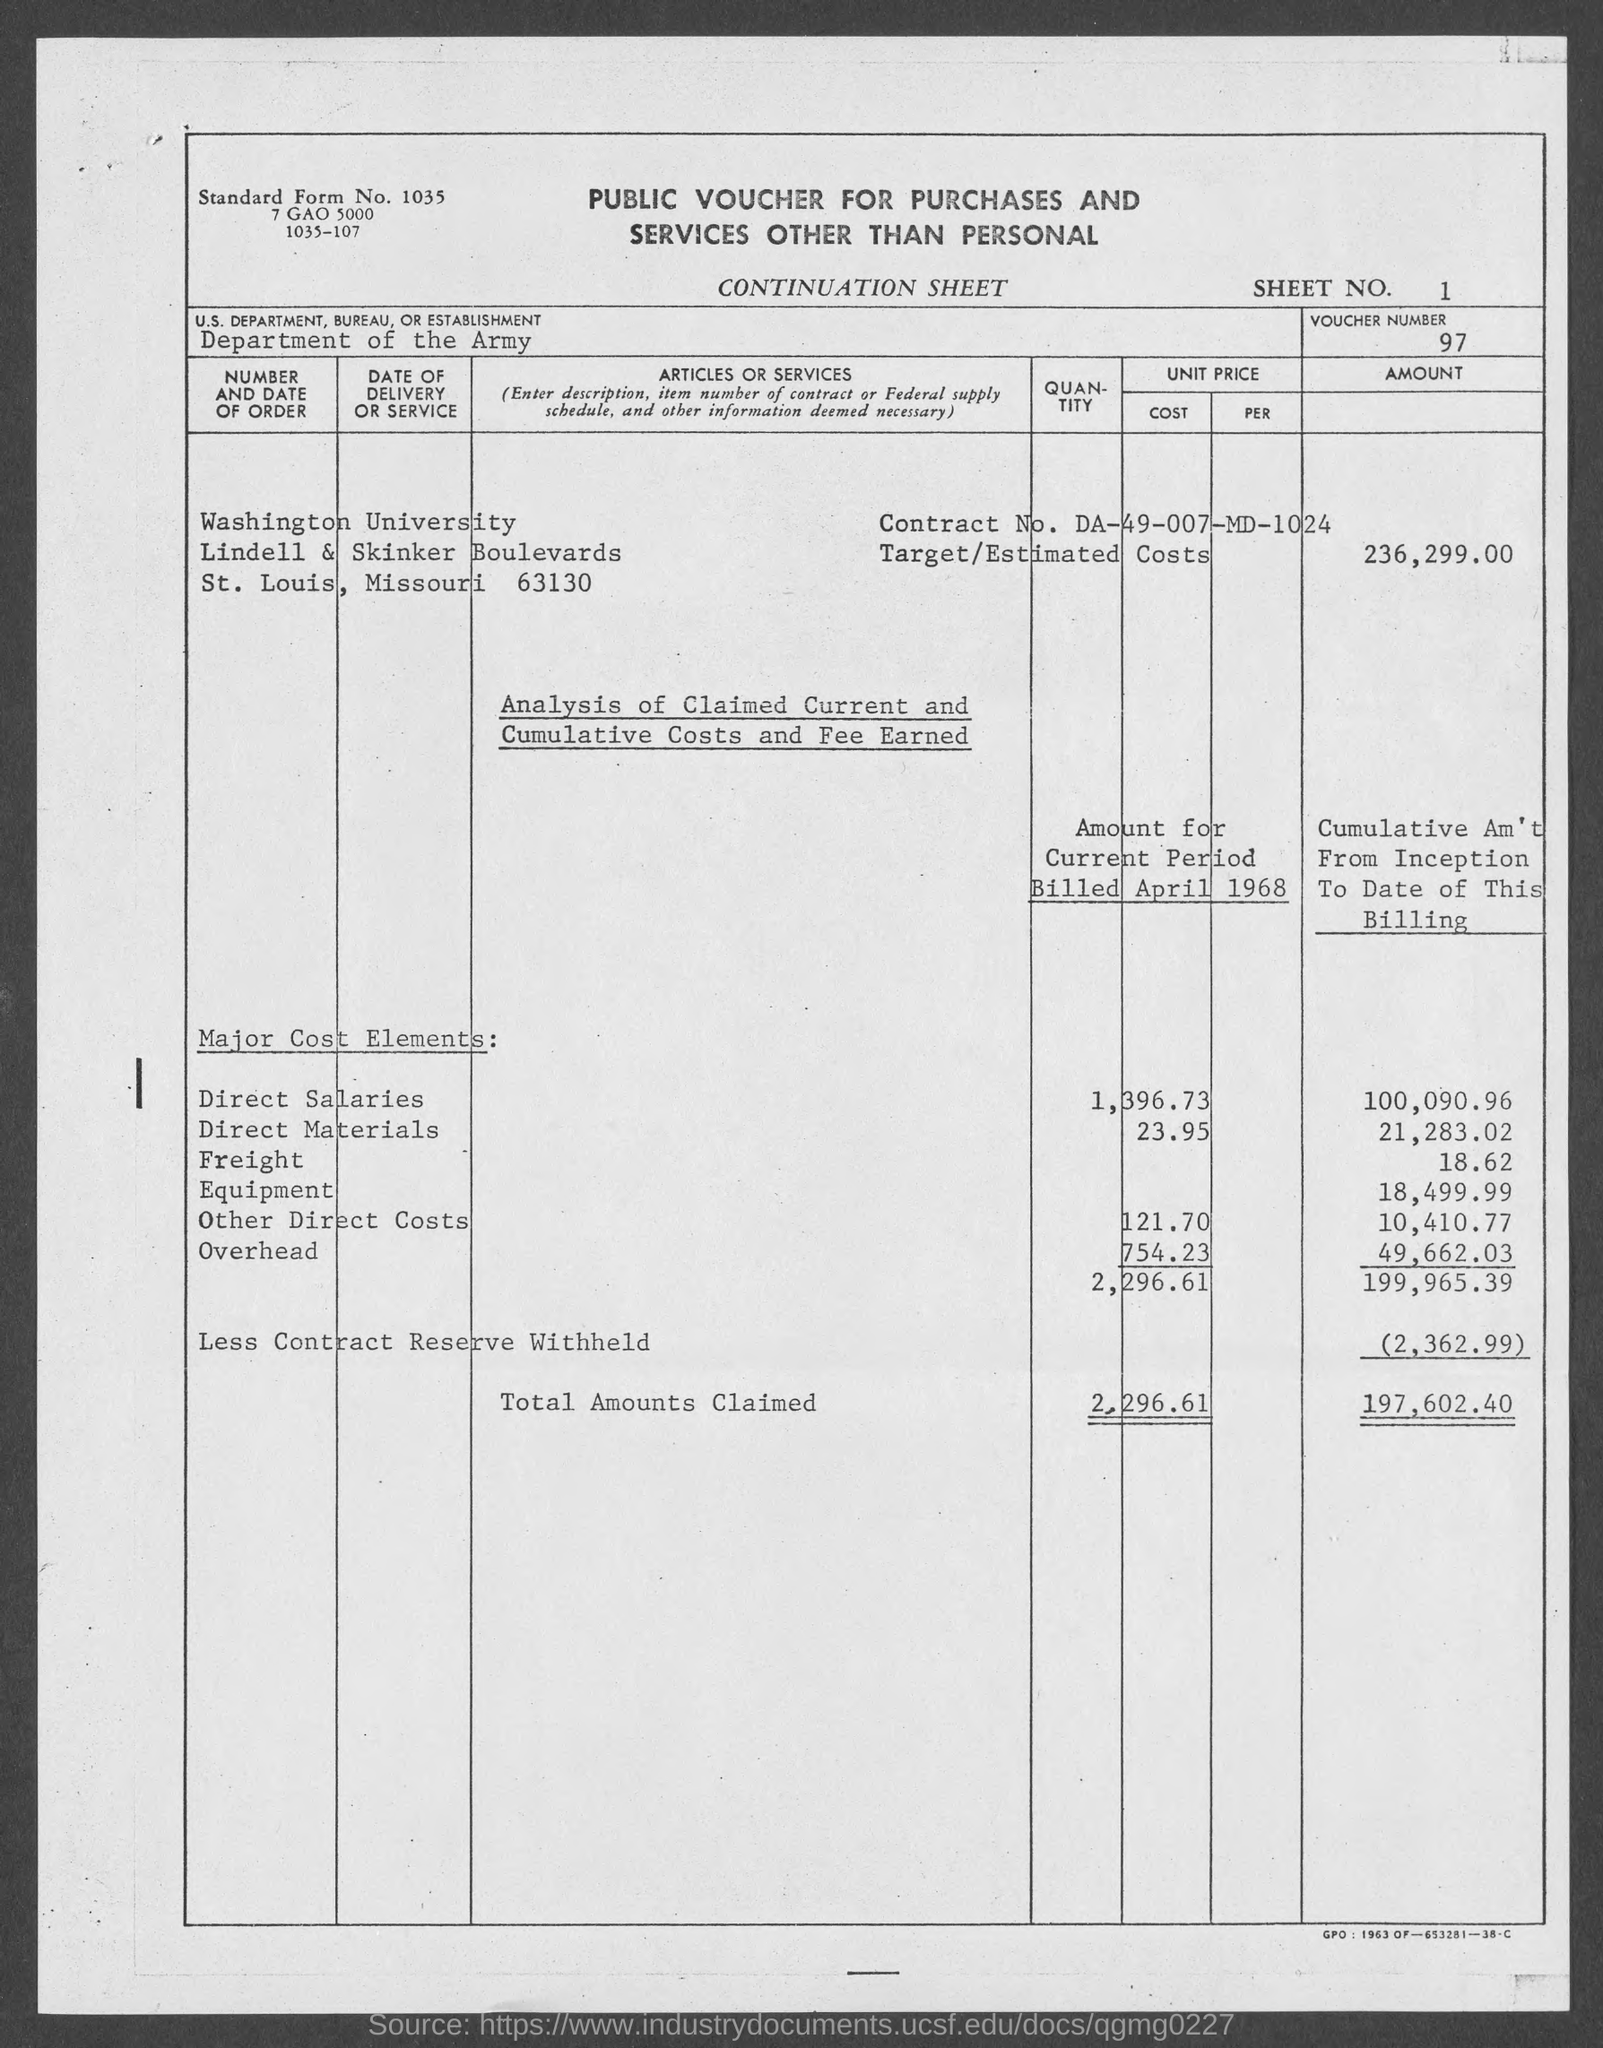What is the sheet no.?
Give a very brief answer. 1. What is the voucher number ?
Offer a very short reply. 97. What is the us. department, bureau, or establishment in voucher?
Provide a short and direct response. Department of the army. What is the street address of washington university ?
Keep it short and to the point. Lindell & Skinker Boulevards. What is the contract no.?
Ensure brevity in your answer.  DA-49-007-MD-1024. What is the target/estimated costs ?
Keep it short and to the point. 236,299.00. In which county is washington university  located?
Provide a succinct answer. St. louis. 